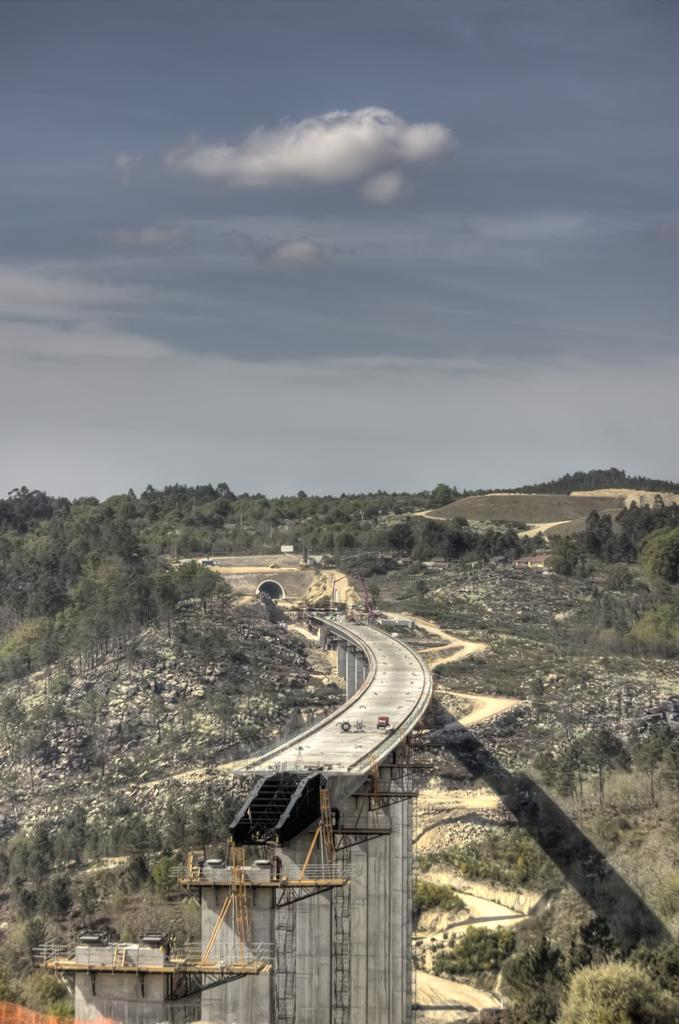What is happening to the bridge in the image? The bridge is under construction in the image. What can be seen below the bridge? The ground is visible in the image. What type of vegetation is present in the image? There are plants and trees in the image. What is visible above the bridge? The sky is visible in the image, and clouds are present in the sky. What type of cord is being used to weave the silk in the image? There is no cord or silk present in the image; it features a bridge under construction. 